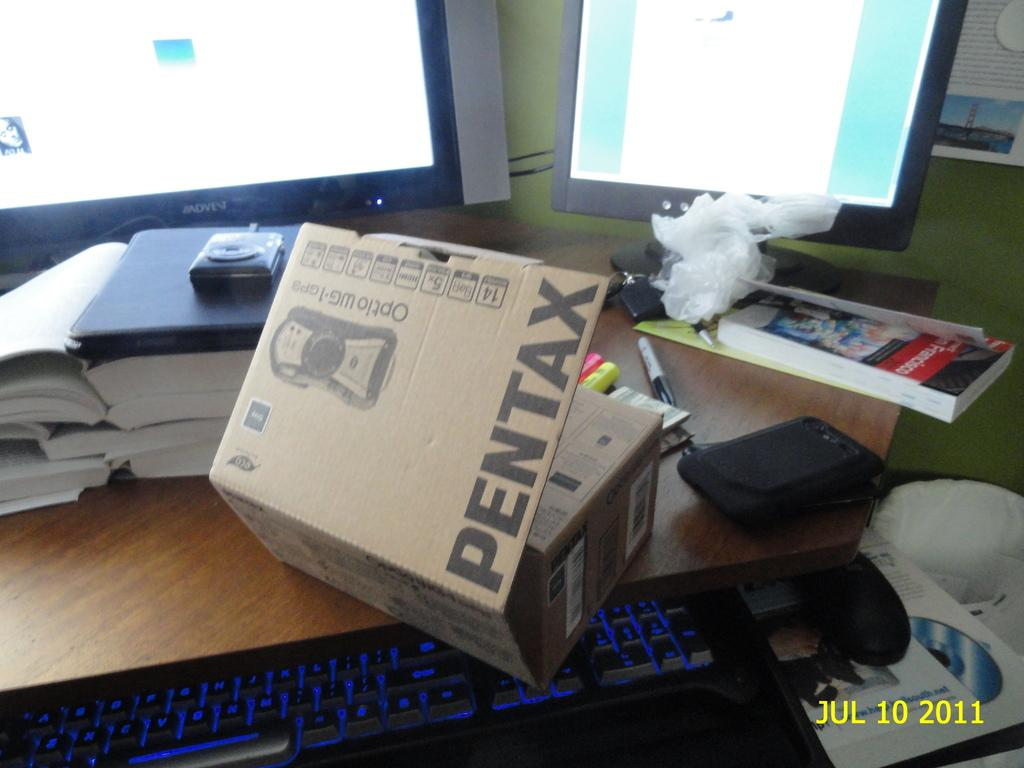<image>
Render a clear and concise summary of the photo. A pentax box on top of a keyboard in front of two monitors. 